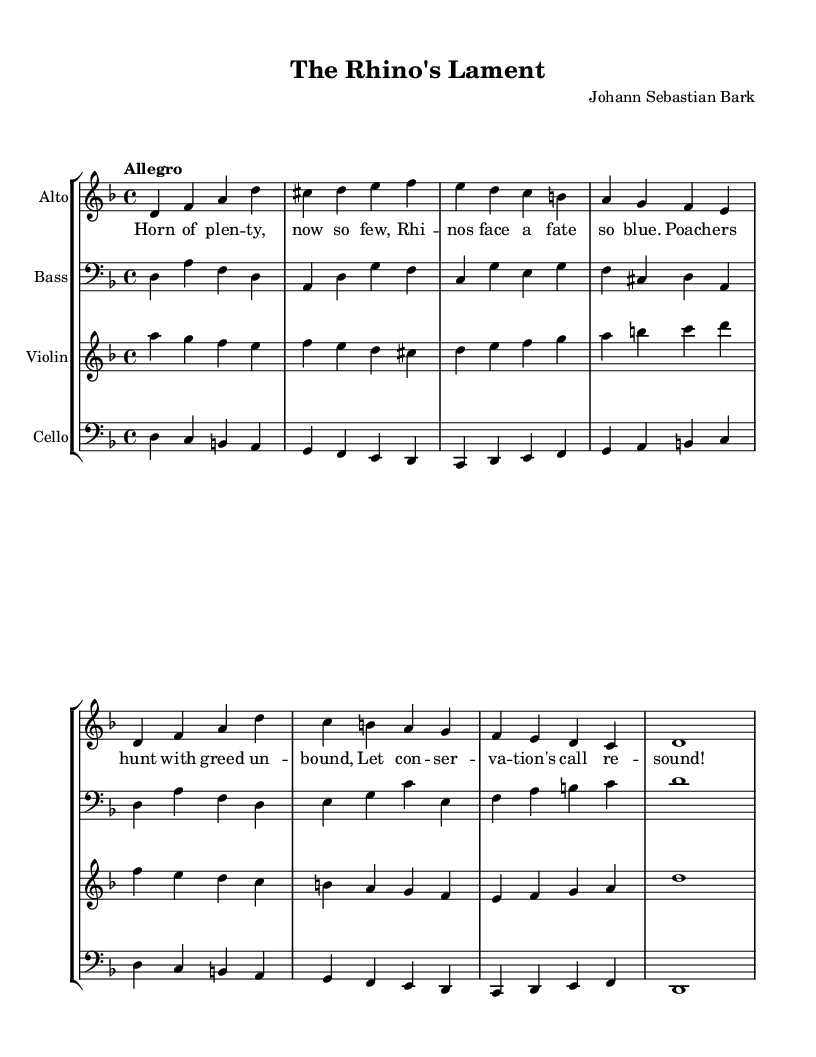What is the key signature of this music? The key signature is D minor, which typically contains one flat (B flat) and includes the notes corresponding to the D minor scale.
Answer: D minor What is the time signature of this music? The time signature is indicated as 4/4, meaning there are four beats in each measure, and a quarter note gets one beat.
Answer: 4/4 What is the tempo marking for this piece? The tempo is marked as Allegro, which suggests a fast and lively pace, typically ranging between 120-168 beats per minute.
Answer: Allegro How many instruments are featured in this score? There are four instruments featured: Alto, Bass, Violin, and Cello. Each has its own staff in the score setup.
Answer: Four What is the mood conveyed through the lyrics of this cantata? The lyrics express a somber mood regarding the endangered status of rhinos and emphasize the urgency of conservation efforts. The use of "Lament" in the title suggests a sense of mourning or sadness.
Answer: Somber Which voice part has the highest pitch? The Alto voice part is generally higher in pitch compared to the Bass, Violin, and Cello, as it is written in the treble clef.
Answer: Alto Is there a specific environmental theme in the lyrics? Yes, the lyrics discuss themes of poaching and conservation, focusing specifically on the plight of rhinos as an endangered species.
Answer: Yes 